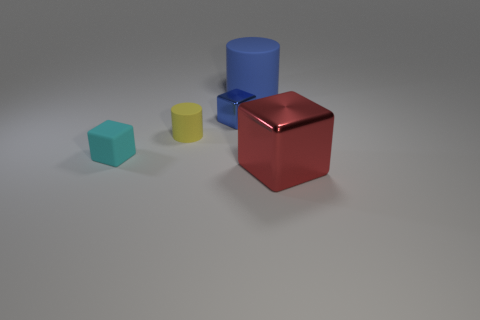There is a tiny object that is to the left of the blue cube and on the right side of the cyan matte block; what material is it?
Your answer should be compact. Rubber. Are there fewer balls than red metallic objects?
Your answer should be compact. Yes. There is a shiny object that is behind the object that is in front of the cyan matte object; what size is it?
Your response must be concise. Small. There is a blue object that is right of the metallic object that is left of the cube that is to the right of the small blue metallic object; what shape is it?
Offer a very short reply. Cylinder. The big object that is the same material as the tiny blue object is what color?
Your answer should be compact. Red. What is the color of the rubber cylinder that is in front of the small cube to the right of the cube on the left side of the tiny blue metal block?
Offer a terse response. Yellow. How many cubes are rubber objects or yellow matte things?
Provide a short and direct response. 1. What material is the large cylinder that is the same color as the tiny metal thing?
Offer a terse response. Rubber. Does the big rubber thing have the same color as the metallic object behind the big metal thing?
Your answer should be compact. Yes. What is the color of the tiny cylinder?
Offer a very short reply. Yellow. 